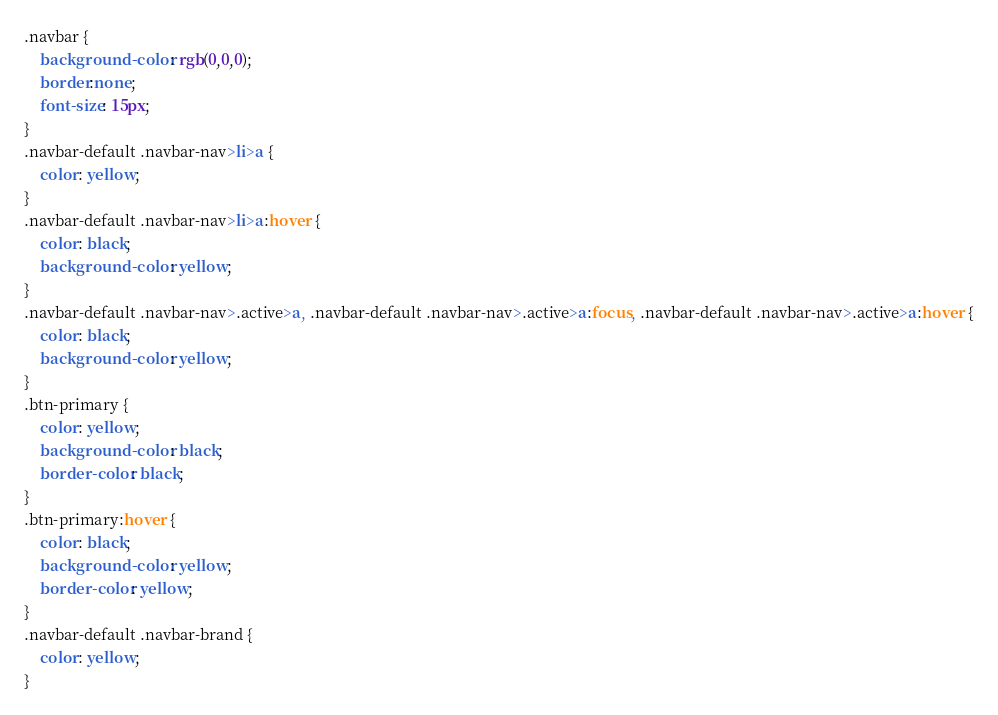<code> <loc_0><loc_0><loc_500><loc_500><_CSS_>.navbar {
	background-color: rgb(0,0,0);
	border:none;
	font-size: 15px;
}
.navbar-default .navbar-nav>li>a {
    color: yellow;
}
.navbar-default .navbar-nav>li>a:hover {
    color: black;
    background-color: yellow;
}
.navbar-default .navbar-nav>.active>a, .navbar-default .navbar-nav>.active>a:focus, .navbar-default .navbar-nav>.active>a:hover {
    color: black;
    background-color: yellow;
}
.btn-primary {
    color: yellow;
    background-color: black;
    border-color: black;
}
.btn-primary:hover {
    color: black;
    background-color: yellow;
    border-color: yellow;
}
.navbar-default .navbar-brand {
    color: yellow;
}</code> 